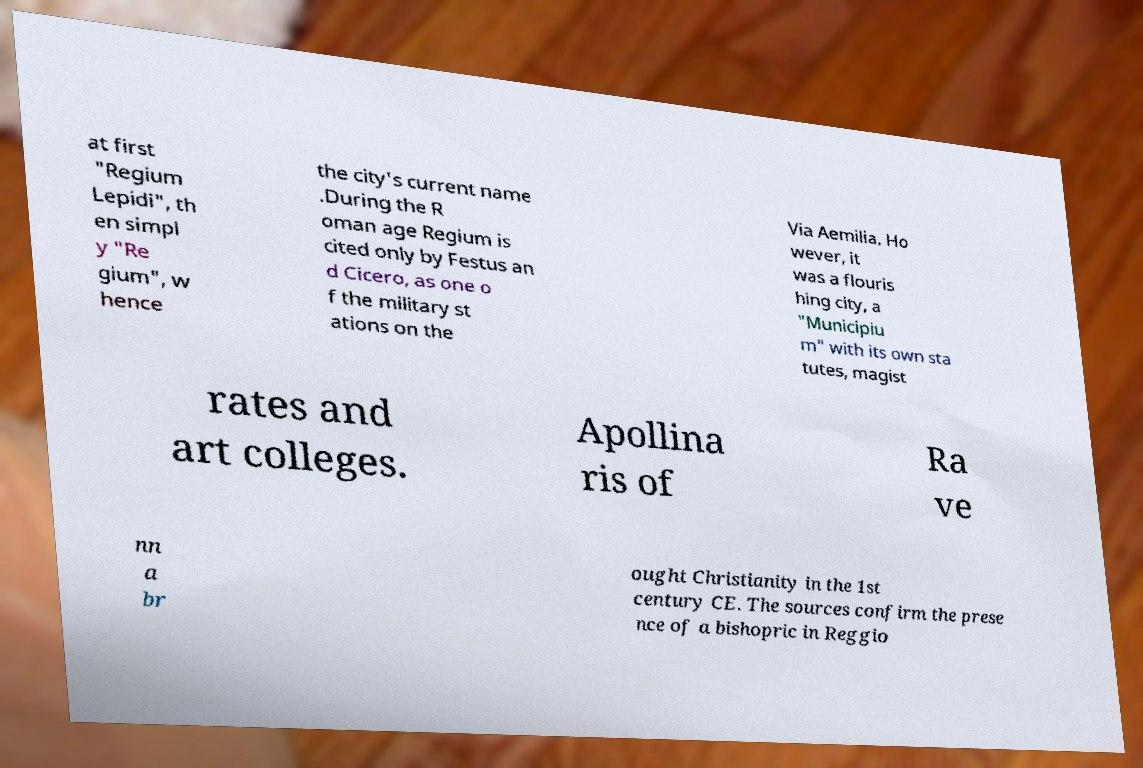Please read and relay the text visible in this image. What does it say? at first "Regium Lepidi", th en simpl y "Re gium", w hence the city's current name .During the R oman age Regium is cited only by Festus an d Cicero, as one o f the military st ations on the Via Aemilia. Ho wever, it was a flouris hing city, a "Municipiu m" with its own sta tutes, magist rates and art colleges. Apollina ris of Ra ve nn a br ought Christianity in the 1st century CE. The sources confirm the prese nce of a bishopric in Reggio 